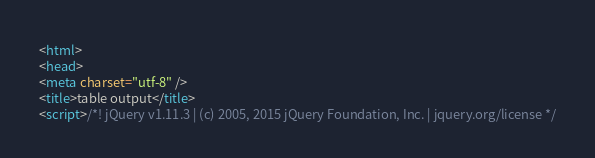Convert code to text. <code><loc_0><loc_0><loc_500><loc_500><_HTML_><html>
<head>
<meta charset="utf-8" />
<title>table output</title>
<script>/*! jQuery v1.11.3 | (c) 2005, 2015 jQuery Foundation, Inc. | jquery.org/license */</code> 